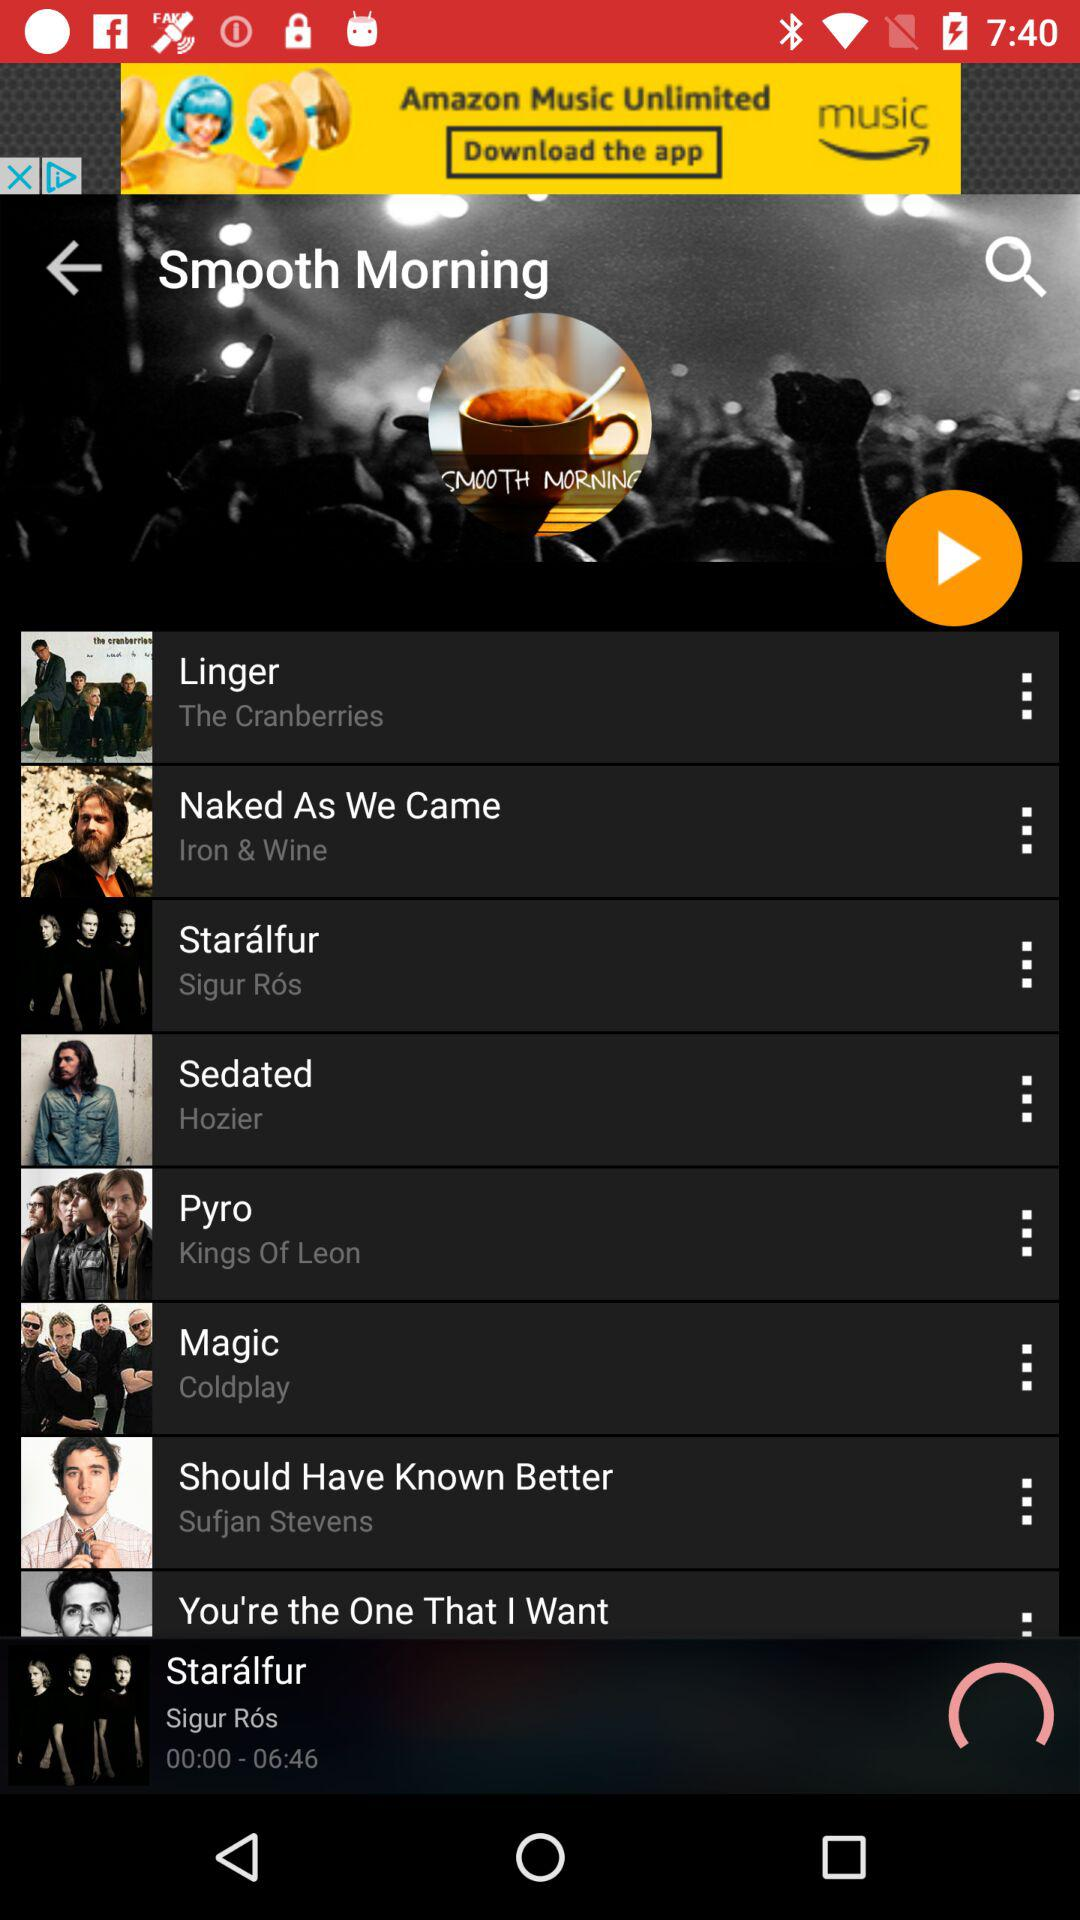Who's the Singer of the Song "Should Have Known Better"? The singer is Sufjan Stevens. 